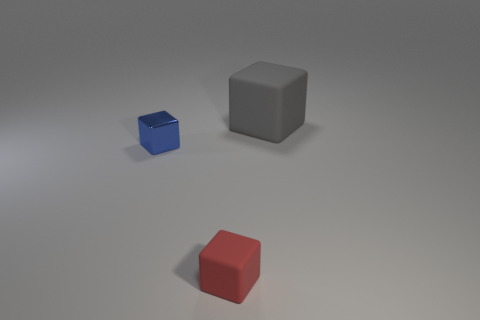How many other objects are there of the same material as the gray block?
Ensure brevity in your answer.  1. There is a object left of the block in front of the object on the left side of the red rubber thing; how big is it?
Make the answer very short. Small. Is the size of the blue metal block the same as the matte cube that is behind the tiny red matte cube?
Your answer should be very brief. No. Is the number of small red things left of the blue block less than the number of tiny gray shiny things?
Your response must be concise. No. How many small blocks have the same color as the big matte block?
Provide a short and direct response. 0. Are there fewer blue metallic blocks than tiny cubes?
Your answer should be compact. Yes. Does the gray thing have the same material as the tiny red cube?
Your answer should be very brief. Yes. How many other objects are the same size as the gray cube?
Your answer should be very brief. 0. The tiny object that is on the left side of the thing in front of the blue thing is what color?
Your answer should be compact. Blue. How many other objects are the same shape as the red rubber thing?
Keep it short and to the point. 2. 